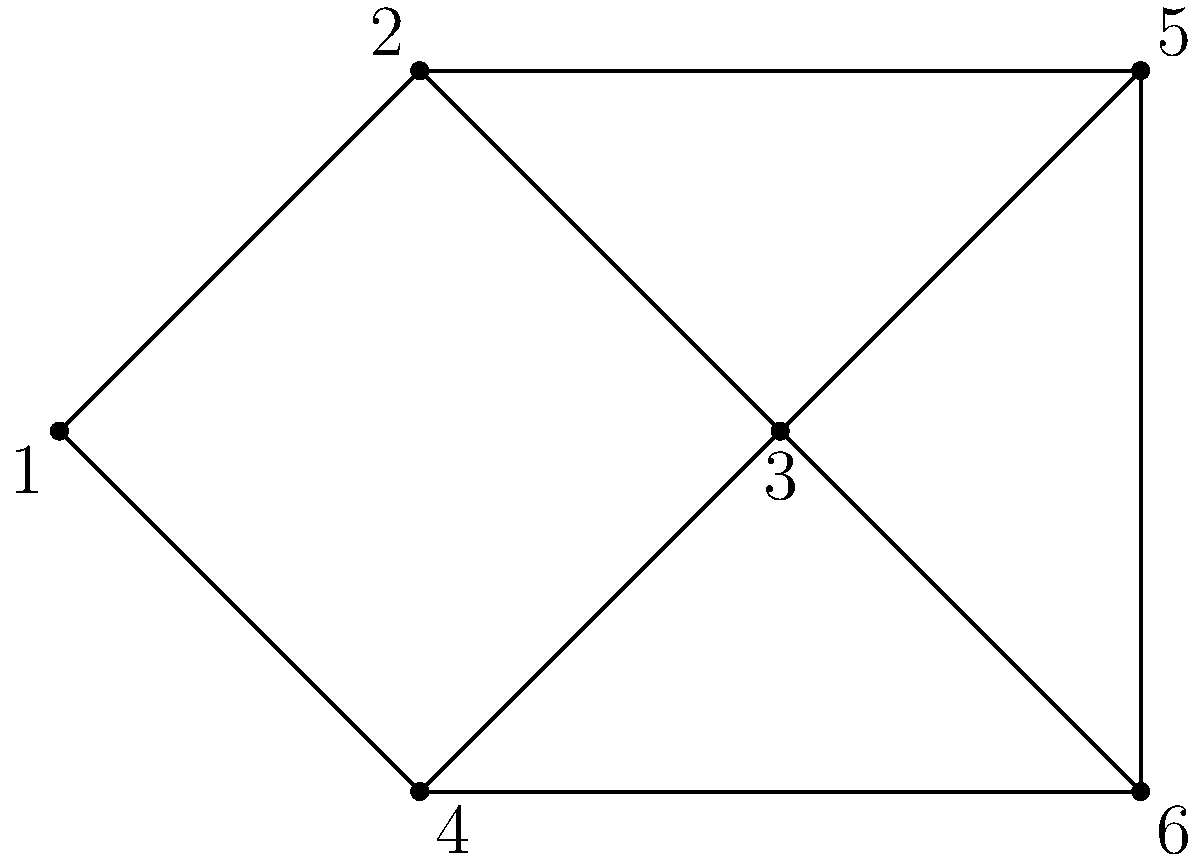As a software developer working with graph algorithms, you're tasked with implementing a function to color a planar graph with the minimum number of colors. Given the planar graph shown above, what is the minimum number of colors required to color this graph such that no two adjacent vertices have the same color? To determine the minimum number of colors required for this planar graph, we'll follow these steps:

1. Recall the Four Color Theorem: Any planar graph can be colored using at most four colors.

2. Analyze the graph structure:
   - The graph has 6 vertices and 9 edges.
   - It forms a planar graph (can be drawn on a plane without edge crossings).

3. Apply the greedy coloring algorithm:
   a. Start with vertex 1: Assign color 1.
   b. Move to vertex 2: It's adjacent to 1, so assign color 2.
   c. For vertex 3: It's adjacent to 2, so we can't use color 2. Assign color 1.
   d. For vertex 4: It's adjacent to 1 and 3, so we need a new color. Assign color 3.
   e. For vertex 5: It's adjacent to 2 and 3, so we can use color 3.
   f. For vertex 6: It's adjacent to 3, 4, and 5. We need a new color. Assign color 4.

4. Verify the coloring:
   - No two adjacent vertices have the same color.
   - We used 4 colors in total.

5. Check if we can reduce the number of colors:
   - Vertex 6 is the only one using color 4.
   - However, it's connected to vertices with colors 1, 3, and 3.
   - We can't reduce the number of colors without creating conflicts.

Therefore, the minimum number of colors required to color this planar graph is 4.
Answer: 4 colors 